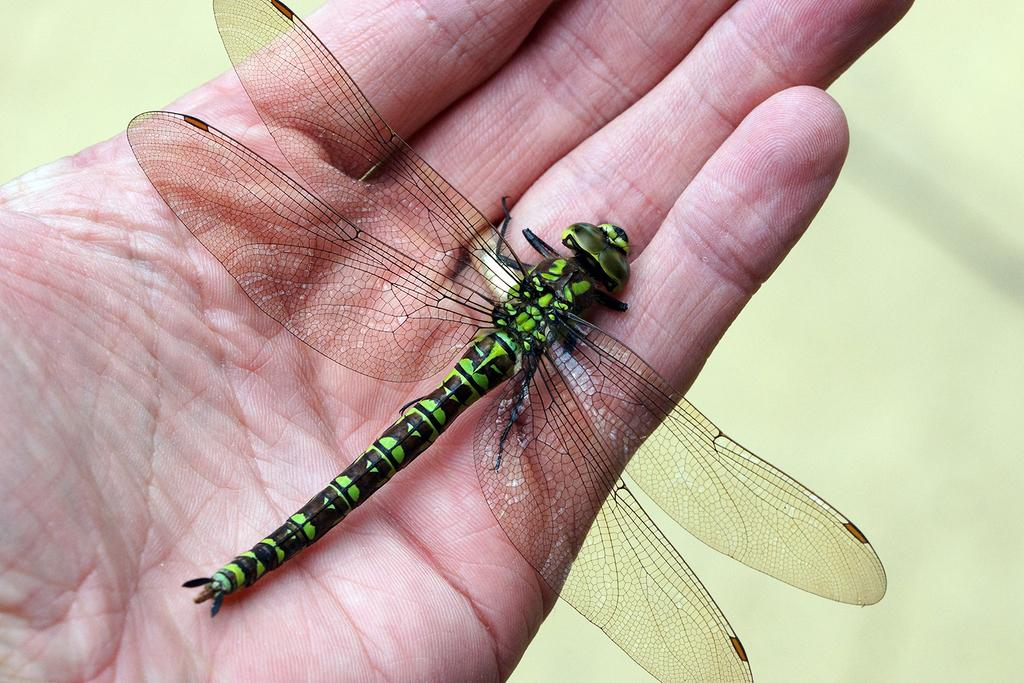What is being held in the hand in the image? A dragonfly is present in the hand. Can you describe the background of the image? The background of the image is blurred. What type of property does the owl own in the image? There is no owl or property present in the image. 